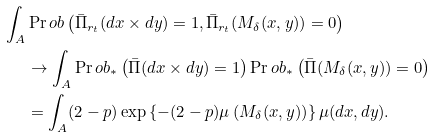Convert formula to latex. <formula><loc_0><loc_0><loc_500><loc_500>\int _ { A } & \Pr o b \left ( \bar { \Pi } _ { r _ { t } } ( d x \times d y ) = 1 , \bar { \Pi } _ { r _ { t } } ( M _ { \delta } ( x , y ) ) = 0 \right ) \\ & \to \int _ { A } \Pr o b _ { * } \left ( \bar { \Pi } ( d x \times d y ) = 1 \right ) \Pr o b _ { * } \left ( \bar { \Pi } ( M _ { \delta } ( x , y ) ) = 0 \right ) \\ & = \int _ { A } ( 2 - p ) \exp \left \{ - ( 2 - p ) \mu \left ( M _ { \delta } ( x , y ) \right ) \right \} \mu ( d x , d y ) .</formula> 